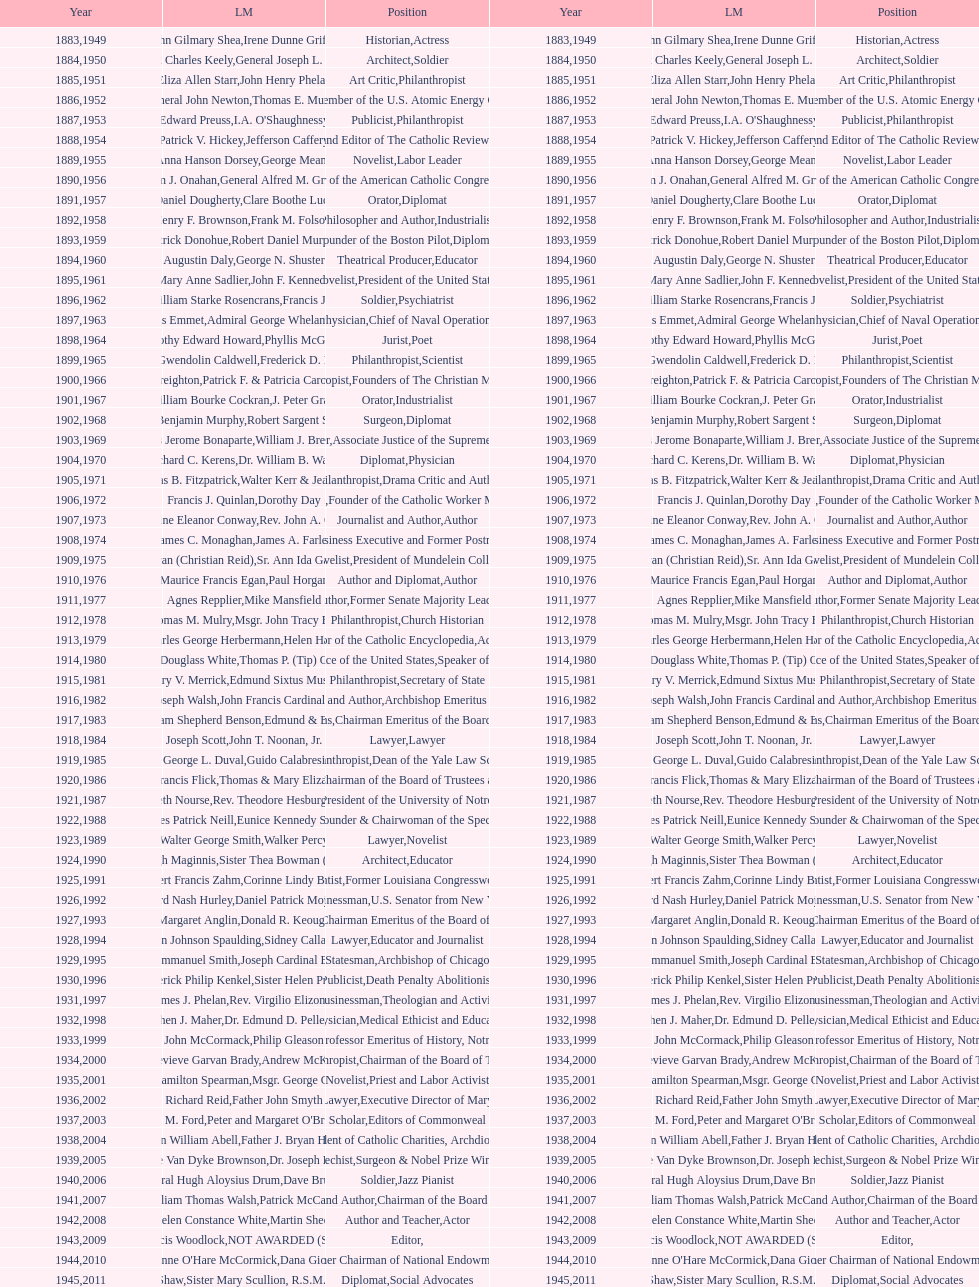What is the name of the laetare medalist listed before edward preuss? General John Newton. 